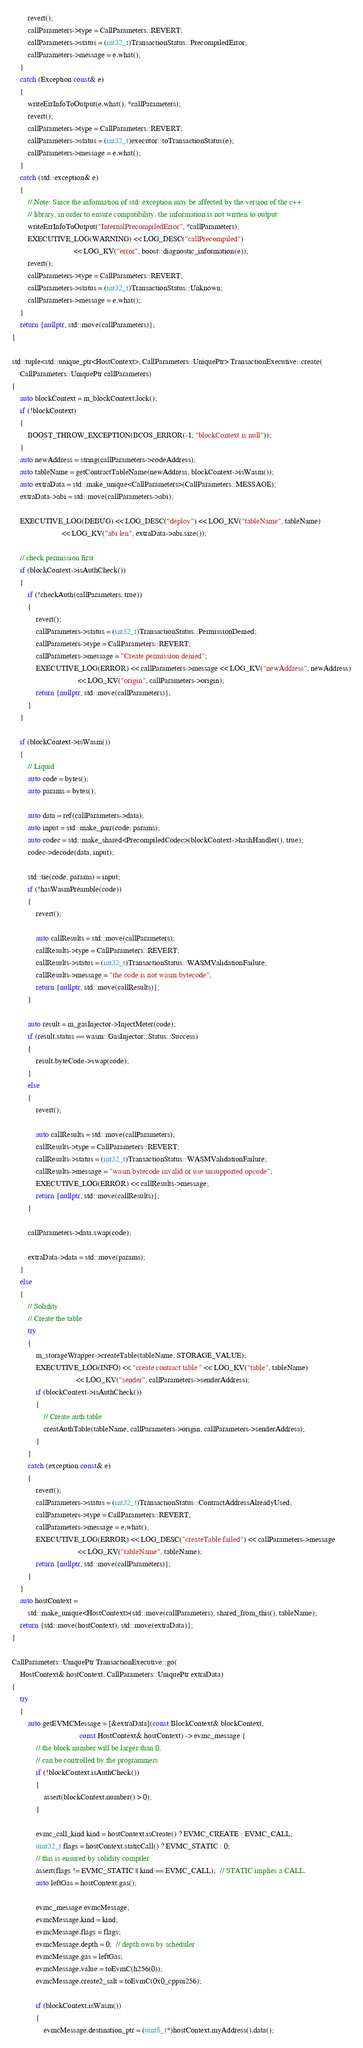Convert code to text. <code><loc_0><loc_0><loc_500><loc_500><_C++_>        revert();
        callParameters->type = CallParameters::REVERT;
        callParameters->status = (int32_t)TransactionStatus::PrecompiledError;
        callParameters->message = e.what();
    }
    catch (Exception const& e)
    {
        writeErrInfoToOutput(e.what(), *callParameters);
        revert();
        callParameters->type = CallParameters::REVERT;
        callParameters->status = (int32_t)executor::toTransactionStatus(e);
        callParameters->message = e.what();
    }
    catch (std::exception& e)
    {
        // Note: Since the information of std::exception may be affected by the version of the c++
        // library, in order to ensure compatibility, the information is not written to output
        writeErrInfoToOutput("InternalPrecompiledError", *callParameters);
        EXECUTIVE_LOG(WARNING) << LOG_DESC("callPrecompiled")
                               << LOG_KV("error", boost::diagnostic_information(e));
        revert();
        callParameters->type = CallParameters::REVERT;
        callParameters->status = (int32_t)TransactionStatus::Unknown;
        callParameters->message = e.what();
    }
    return {nullptr, std::move(callParameters)};
}

std::tuple<std::unique_ptr<HostContext>, CallParameters::UniquePtr> TransactionExecutive::create(
    CallParameters::UniquePtr callParameters)
{
    auto blockContext = m_blockContext.lock();
    if (!blockContext)
    {
        BOOST_THROW_EXCEPTION(BCOS_ERROR(-1, "blockContext is null"));
    }
    auto newAddress = string(callParameters->codeAddress);
    auto tableName = getContractTableName(newAddress, blockContext->isWasm());
    auto extraData = std::make_unique<CallParameters>(CallParameters::MESSAGE);
    extraData->abi = std::move(callParameters->abi);

    EXECUTIVE_LOG(DEBUG) << LOG_DESC("deploy") << LOG_KV("tableName", tableName)
                         << LOG_KV("abi len", extraData->abi.size());

    // check permission first
    if (blockContext->isAuthCheck())
    {
        if (!checkAuth(callParameters, true))
        {
            revert();
            callParameters->status = (int32_t)TransactionStatus::PermissionDenied;
            callParameters->type = CallParameters::REVERT;
            callParameters->message = "Create permission denied";
            EXECUTIVE_LOG(ERROR) << callParameters->message << LOG_KV("newAddress", newAddress)
                                 << LOG_KV("origin", callParameters->origin);
            return {nullptr, std::move(callParameters)};
        }
    }

    if (blockContext->isWasm())
    {
        // Liquid
        auto code = bytes();
        auto params = bytes();

        auto data = ref(callParameters->data);
        auto input = std::make_pair(code, params);
        auto codec = std::make_shared<PrecompiledCodec>(blockContext->hashHandler(), true);
        codec->decode(data, input);

        std::tie(code, params) = input;
        if (!hasWasmPreamble(code))
        {
            revert();

            auto callResults = std::move(callParameters);
            callResults->type = CallParameters::REVERT;
            callResults->status = (int32_t)TransactionStatus::WASMValidationFailure;
            callResults->message = "the code is not wasm bytecode";
            return {nullptr, std::move(callResults)};
        }

        auto result = m_gasInjector->InjectMeter(code);
        if (result.status == wasm::GasInjector::Status::Success)
        {
            result.byteCode->swap(code);
        }
        else
        {
            revert();

            auto callResults = std::move(callParameters);
            callResults->type = CallParameters::REVERT;
            callResults->status = (int32_t)TransactionStatus::WASMValidationFailure;
            callResults->message = "wasm bytecode invalid or use unsupported opcode";
            EXECUTIVE_LOG(ERROR) << callResults->message;
            return {nullptr, std::move(callResults)};
        }

        callParameters->data.swap(code);

        extraData->data = std::move(params);
    }
    else
    {
        // Solidity
        // Create the table
        try
        {
            m_storageWrapper->createTable(tableName, STORAGE_VALUE);
            EXECUTIVE_LOG(INFO) << "create contract table " << LOG_KV("table", tableName)
                                << LOG_KV("sender", callParameters->senderAddress);
            if (blockContext->isAuthCheck())
            {
                // Create auth table
                creatAuthTable(tableName, callParameters->origin, callParameters->senderAddress);
            }
        }
        catch (exception const& e)
        {
            revert();
            callParameters->status = (int32_t)TransactionStatus::ContractAddressAlreadyUsed;
            callParameters->type = CallParameters::REVERT;
            callParameters->message = e.what();
            EXECUTIVE_LOG(ERROR) << LOG_DESC("createTable failed") << callParameters->message
                                 << LOG_KV("tableName", tableName);
            return {nullptr, std::move(callParameters)};
        }
    }
    auto hostContext =
        std::make_unique<HostContext>(std::move(callParameters), shared_from_this(), tableName);
    return {std::move(hostContext), std::move(extraData)};
}

CallParameters::UniquePtr TransactionExecutive::go(
    HostContext& hostContext, CallParameters::UniquePtr extraData)
{
    try
    {
        auto getEVMCMessage = [&extraData](const BlockContext& blockContext,
                                  const HostContext& hostContext) -> evmc_message {
            // the block number will be larger than 0,
            // can be controlled by the programmers
            if (!blockContext.isAuthCheck())
            {
                assert(blockContext.number() > 0);
            }

            evmc_call_kind kind = hostContext.isCreate() ? EVMC_CREATE : EVMC_CALL;
            uint32_t flags = hostContext.staticCall() ? EVMC_STATIC : 0;
            // this is ensured by solidity compiler
            assert(flags != EVMC_STATIC || kind == EVMC_CALL);  // STATIC implies a CALL.
            auto leftGas = hostContext.gas();

            evmc_message evmcMessage;
            evmcMessage.kind = kind;
            evmcMessage.flags = flags;
            evmcMessage.depth = 0;  // depth own by scheduler
            evmcMessage.gas = leftGas;
            evmcMessage.value = toEvmC(h256(0));
            evmcMessage.create2_salt = toEvmC(0x0_cppui256);

            if (blockContext.isWasm())
            {
                evmcMessage.destination_ptr = (uint8_t*)hostContext.myAddress().data();</code> 